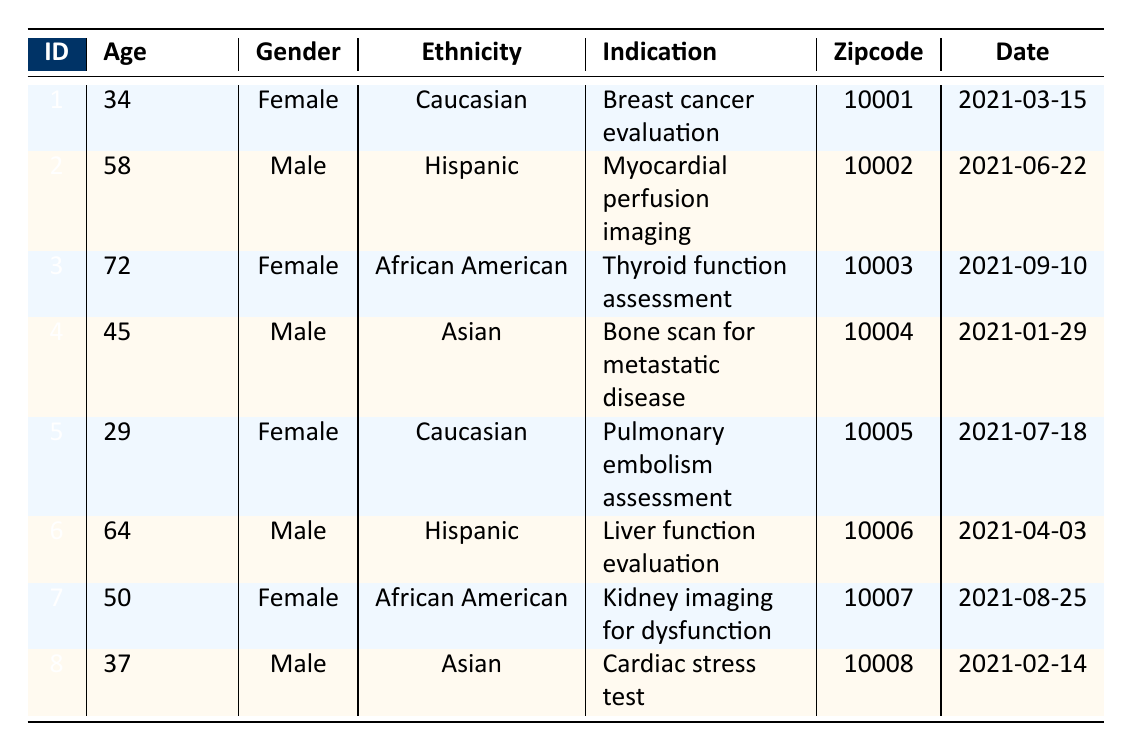What is the age of the patient with ID 3? The table lists each patient's age along with their ID. For patient ID 3, the age is directly provided as 72.
Answer: 72 How many male patients are in the data? By examining the "Gender" column, the male patients are ID 2, ID 4, ID 6, and ID 8. There are four entries with "Male."
Answer: 4 What is the indication for patient ID 1? The table specifies that the indication for patient ID 1 is "Breast cancer evaluation." This is directly stated in the corresponding row for this patient.
Answer: Breast cancer evaluation Which ethnicity has the highest representation among the patients? The table displays the ethnicities of all patients: Caucasian, Hispanic, African American, and Asian. Caucasian appears twice (IDs 1 and 5), while Hispanic and African American each appear twice. Asian appears twice. Thus, there’s no single highest representation; however, Caucasian, Hispanic, and African American are equal with two patients each.
Answer: Caucasian, Hispanic, African American (tied) What is the average age of female patients? The ages of female patients are: 34 (ID 1), 72 (ID 3), 29 (ID 5), and 50 (ID 7). To find the average, sum these ages: 34 + 72 + 29 + 50 = 185. There are 4 female patients, so the average age is 185 / 4 = 46.25.
Answer: 46.25 Is there a patient aged over 60? Looking at the "Age" column, patient ID 2 is 58, patient ID 3 is 72, and patient ID 6 is 64. Only patient ID 3 and patient ID 6 are over 60, so the statement is true.
Answer: Yes What percentage of patients have an indication related to cancer? The indications related to cancer are: "Breast cancer evaluation" (ID 1) and "Bone scan for metastatic disease" (ID 4). There are 2 cancer-related indications out of a total of 8 patients. The percentage is (2 / 8) * 100 = 25%.
Answer: 25% Which gender has more patients receiving technetium-99m imaging? Counting the patients, there are 4 males (IDs 2, 4, 6, 8) and 4 females (IDs 1, 3, 5, 7). Since they are equal, no gender has more patients.
Answer: Equal How many patients have a zipcode starting with "1000"? The zipcodes listed are 10001, 10002, 10003, 10004, 10005, 10006, 10007, and 10008. All these zipcodes start with "1000," meaning all 8 patients fit this criterion.
Answer: 8 